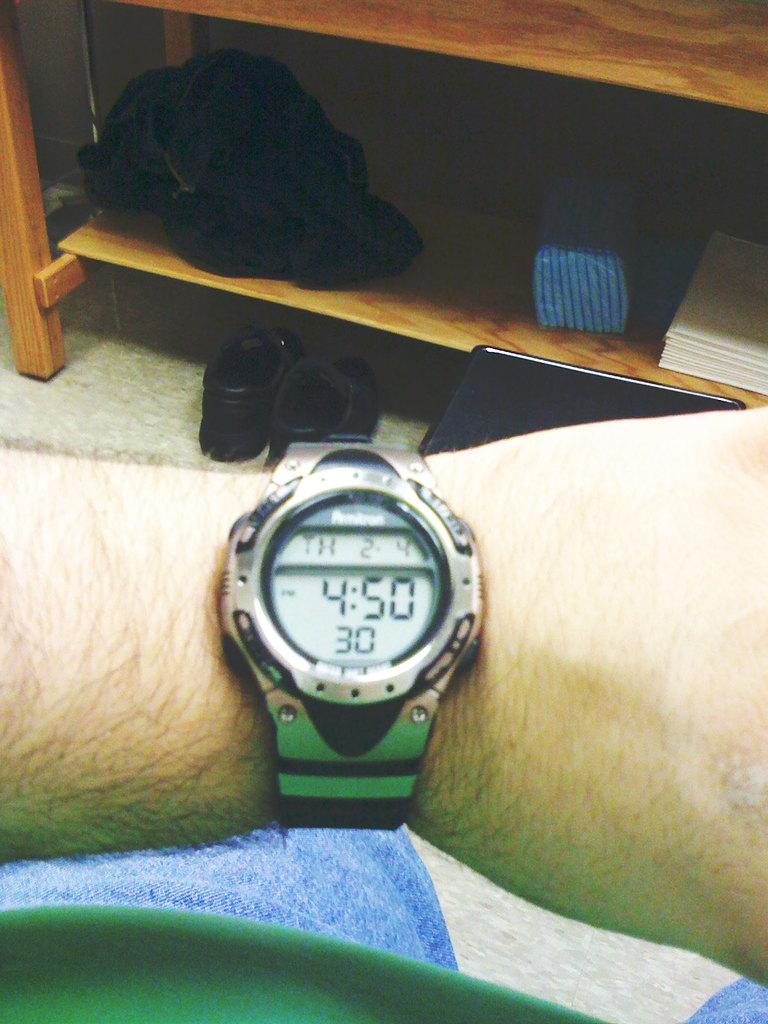<image>
Describe the image concisely. A wrist watch that reads 4:50 P.M., Th 2-4. 